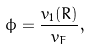<formula> <loc_0><loc_0><loc_500><loc_500>\phi = \frac { v _ { 1 } ( R ) } { v _ { F } } ,</formula> 